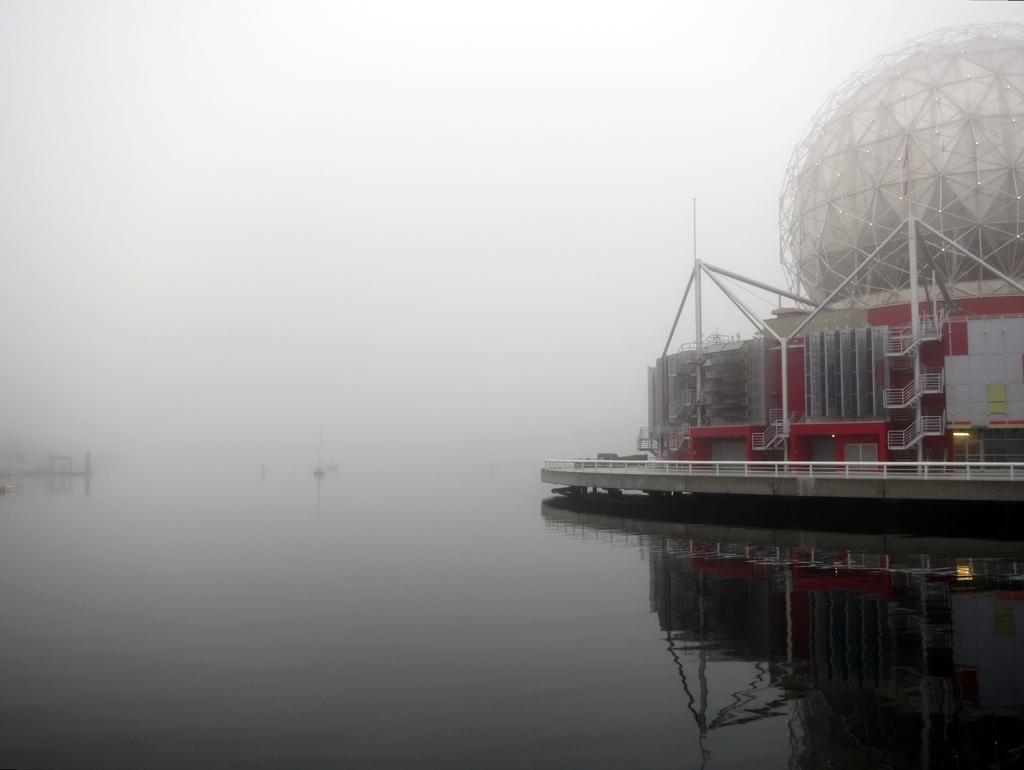Could you give a brief overview of what you see in this image? In this picture we can see ship above the water. In the background of the image it is blurry and we can see sky. 